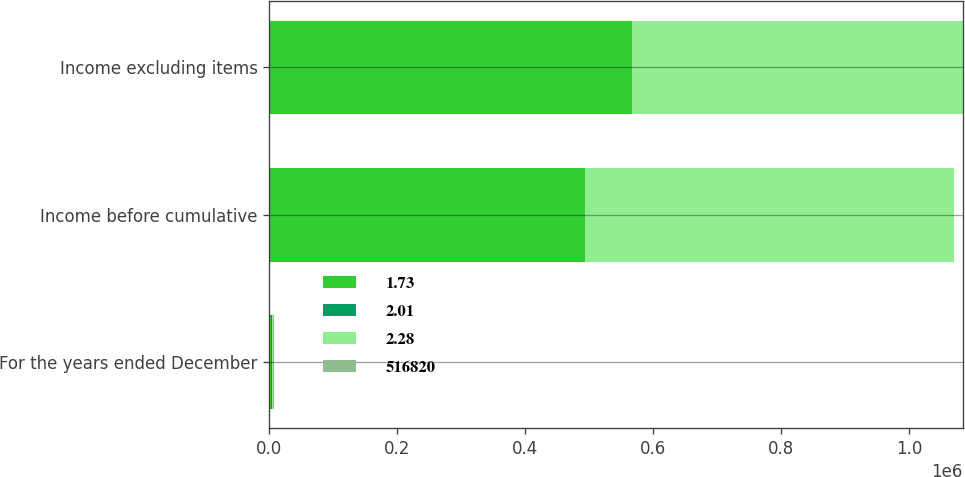<chart> <loc_0><loc_0><loc_500><loc_500><stacked_bar_chart><ecel><fcel>For the years ended December<fcel>Income before cumulative<fcel>Income excluding items<nl><fcel>1.73<fcel>2005<fcel>493244<fcel>567265<nl><fcel>2.01<fcel>2005<fcel>1.99<fcel>2.28<nl><fcel>2.28<fcel>2004<fcel>577901<fcel>516820<nl><fcel>516820<fcel>2004<fcel>2.25<fcel>2.01<nl></chart> 